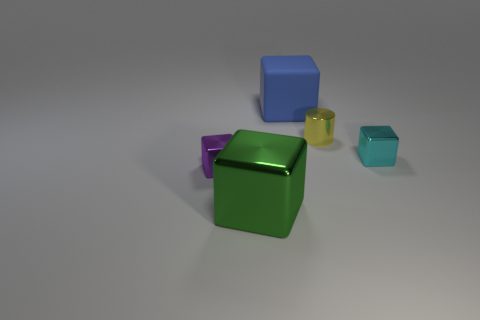Subtract 1 cubes. How many cubes are left? 3 Add 4 tiny red matte objects. How many objects exist? 9 Subtract all blocks. How many objects are left? 1 Add 1 small blocks. How many small blocks exist? 3 Subtract 1 yellow cylinders. How many objects are left? 4 Subtract all big matte objects. Subtract all large objects. How many objects are left? 2 Add 1 tiny yellow objects. How many tiny yellow objects are left? 2 